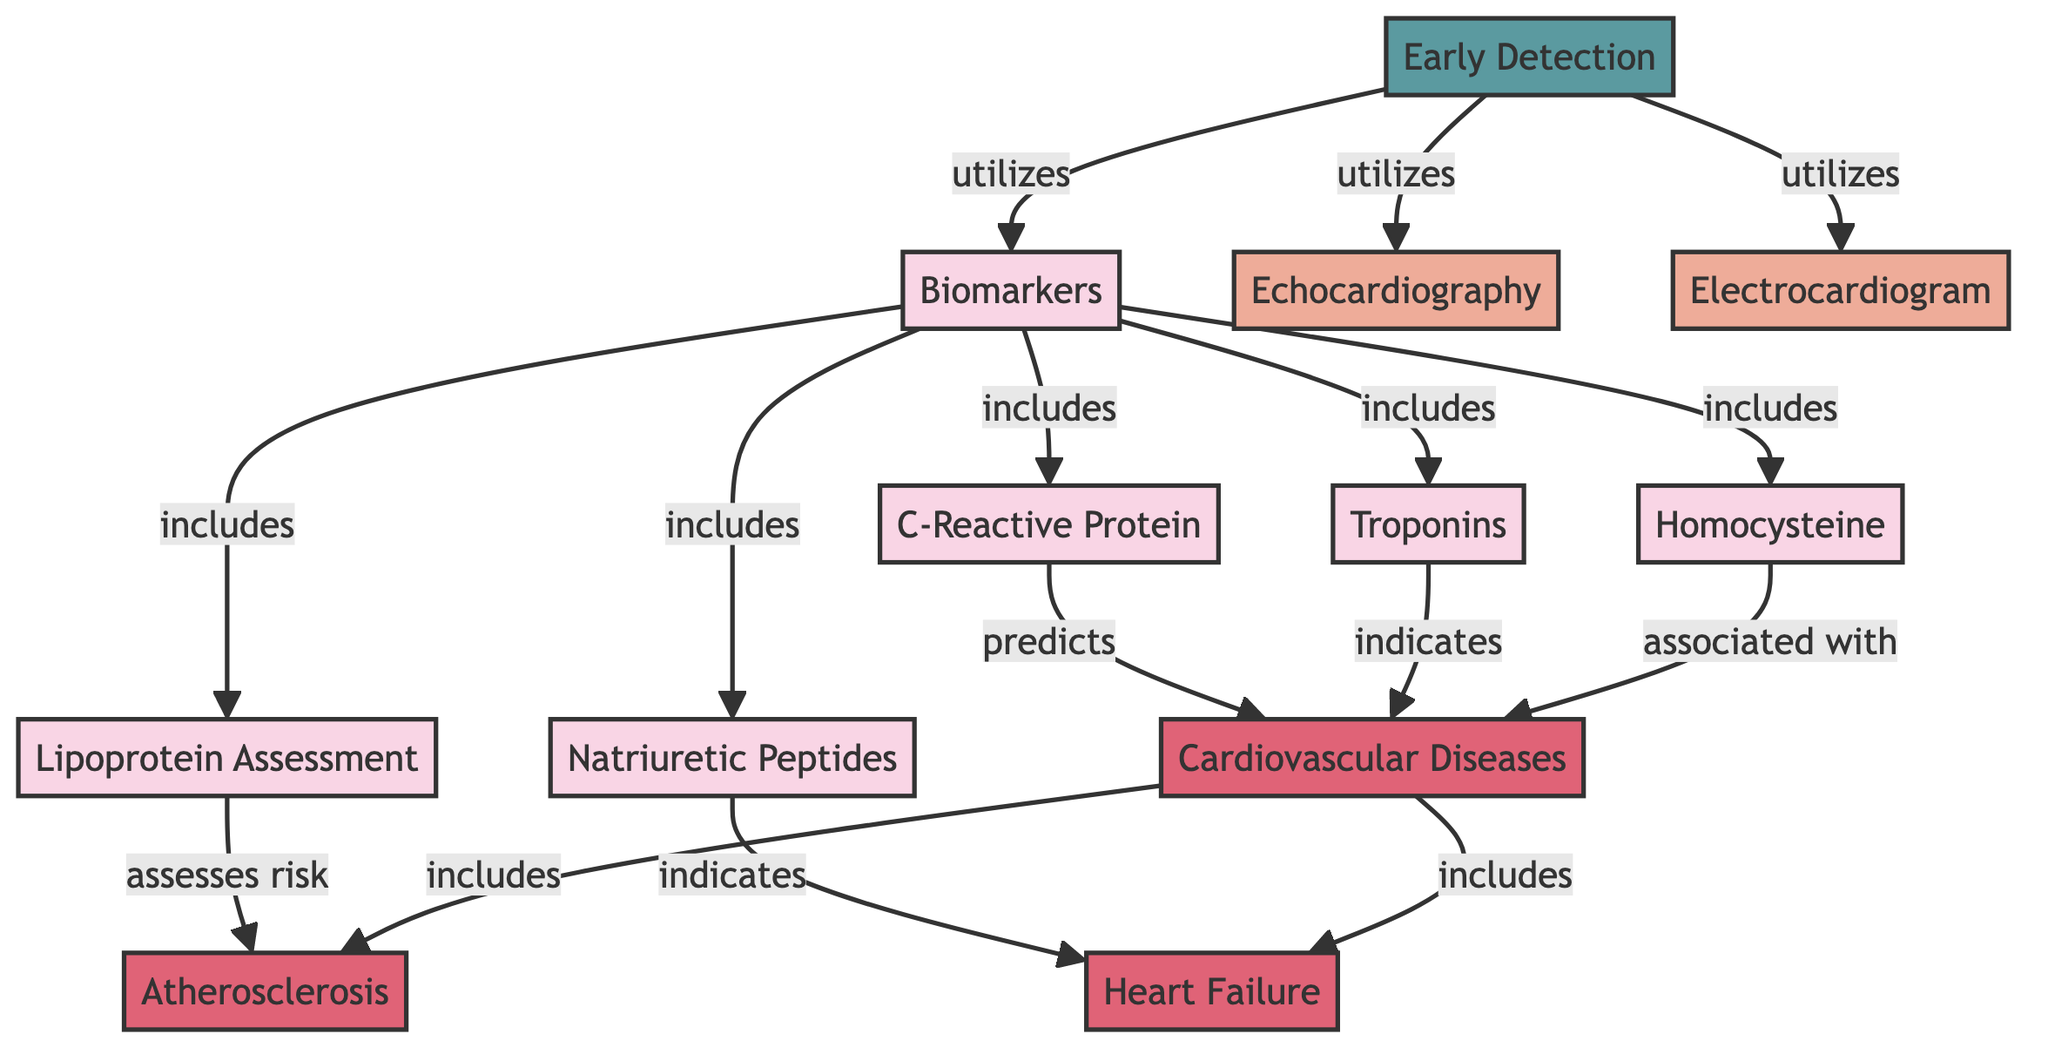What are the biomarkers included in this diagram? The diagram shows five biomarkers: C-Reactive Protein, Troponins, Homocysteine, Natriuretic Peptides, and Lipoprotein Assessment. These are directly connected to the "Biomarkers" node, indicating they are part of this category.
Answer: C-Reactive Protein, Troponins, Homocysteine, Natriuretic Peptides, Lipoprotein Assessment How many diseases are listed under Cardiovascular Diseases? According to the diagram, Cardiovascular Diseases includes two specific diseases: Atherosclerosis and Heart Failure. This is derived from the direct connection showing the relationship between CVD and these diseases.
Answer: 2 Which biomarker is associated with Cardiovascular Diseases? Looking at the diagram, Homocysteine is specifically labeled as "associated with" Cardiovascular Diseases. This label indicates a direct link from the Homocysteine biomarker to the CVD node.
Answer: Homocysteine What diagnostic methods are utilized for Early Detection? The diagram indicates three methods for Early Detection: Biomarkers, Echocardiography, and Electrocardiogram. These nodes connect directly to the Early Detection node, showing their use.
Answer: Biomarkers, Echocardiography, Electrocardiogram Which biomarker indicates Heart Failure? The diagram specifies that the Natriuretic Peptides biomarker "indicates" Heart Failure. This connection shows that Natriuretic Peptides directly relate to the Heart Failure disease node.
Answer: Natriuretic Peptides Which disease is predicted by C-Reactive Protein? The diagram shows that C-Reactive Protein "predicts" Cardiovascular Diseases. This relationship is demonstrated by the directed link from the CRP node to the CVD node.
Answer: Cardiovascular Diseases What is the role of Lipoprotein Assessment in this context? According to the diagram, Lipoprotein Assessment "assesses risk" for Atherosclerosis. This indicates its specific function within the broader context of disease detection related to cardiovascular health.
Answer: Assesses risk How do the diagnostic methods relate to Early Detection? The diagram indicates that both biomarkers and specific diagnostic methods (Echocardiography and Electrocardiogram) "utilize" Early Detection. This suggests they contribute to identifying cardiovascular diseases early.
Answer: Utilize 